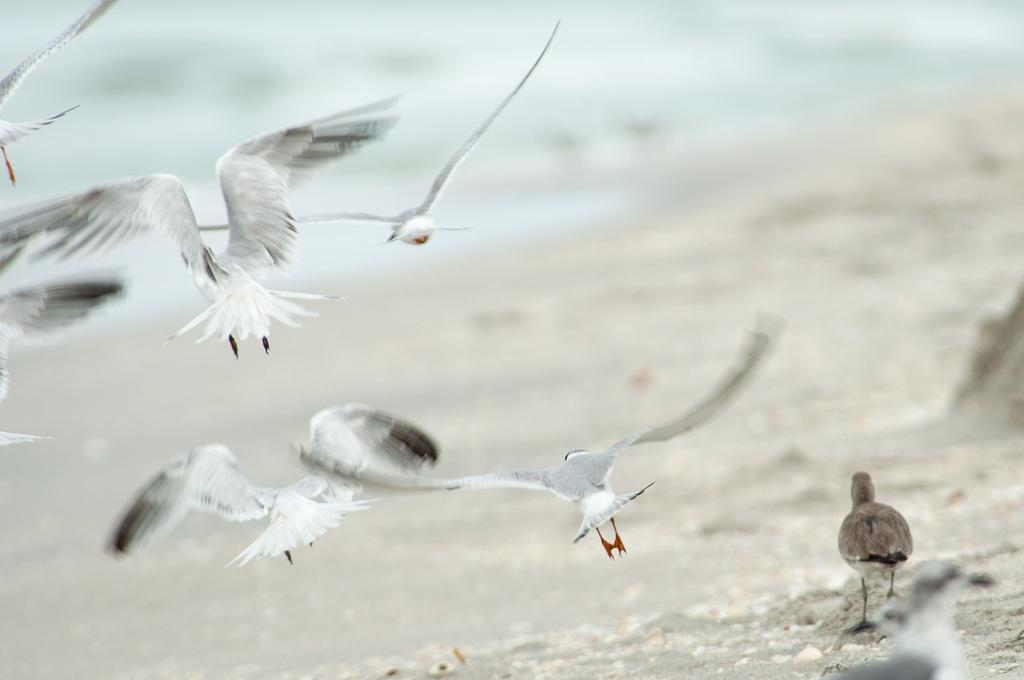What can be seen on the right side of the image? There are two birds standing on the sand on the right side of the image. What are some of the birds doing in the image? There are a few birds flying in the air. What type of environment is depicted in the image? There is water visible in the background of the image, suggesting a beach or coastal setting. What type of rod is being used to treat the wound on the bird in the image? There is no bird with a wound in the image, and no rod is present. 